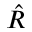Convert formula to latex. <formula><loc_0><loc_0><loc_500><loc_500>\hat { R }</formula> 